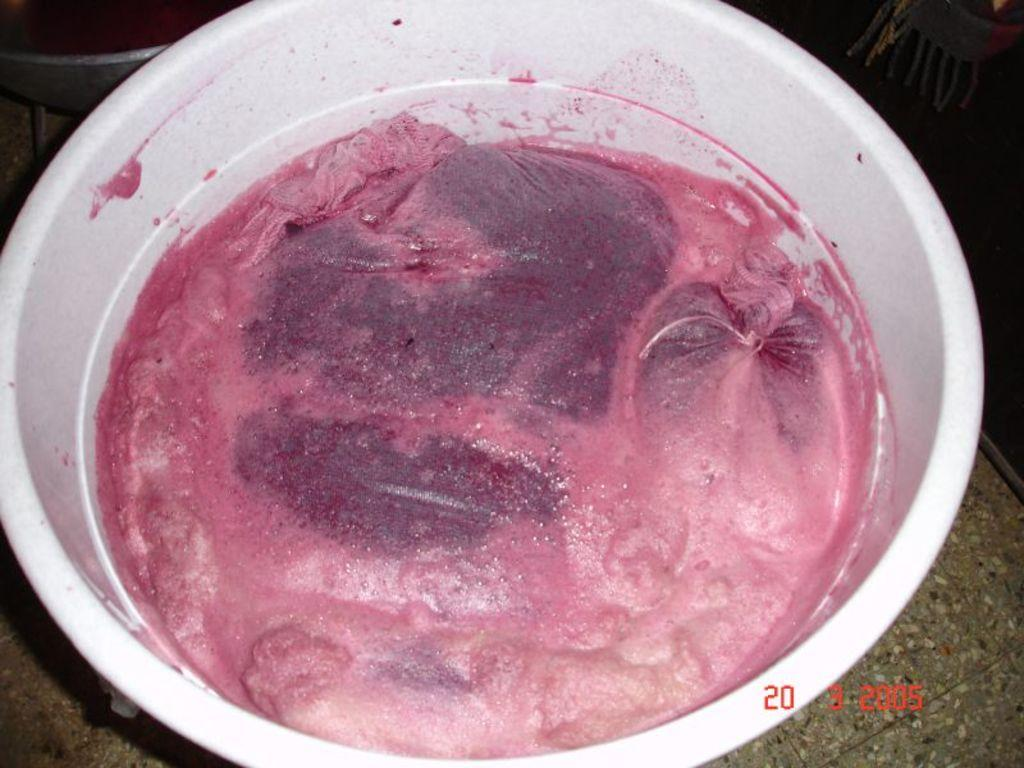What is the main subject of the image? There is a food item in the image. How is the food item contained or presented? The food item is in a plastic bowl. What type of star ornament is hanging above the food item in the image? There is no star ornament present in the image; it only features a food item in a plastic bowl. 